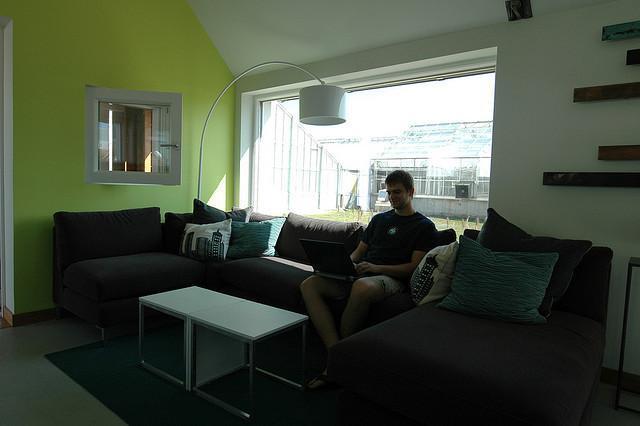What are his fingers touching?
Choose the right answer from the provided options to respond to the question.
Options: Legs, charger, keyboard, screen. Keyboard. 